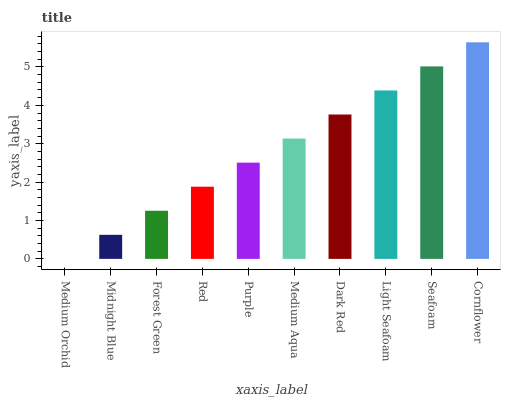Is Medium Orchid the minimum?
Answer yes or no. Yes. Is Cornflower the maximum?
Answer yes or no. Yes. Is Midnight Blue the minimum?
Answer yes or no. No. Is Midnight Blue the maximum?
Answer yes or no. No. Is Midnight Blue greater than Medium Orchid?
Answer yes or no. Yes. Is Medium Orchid less than Midnight Blue?
Answer yes or no. Yes. Is Medium Orchid greater than Midnight Blue?
Answer yes or no. No. Is Midnight Blue less than Medium Orchid?
Answer yes or no. No. Is Medium Aqua the high median?
Answer yes or no. Yes. Is Purple the low median?
Answer yes or no. Yes. Is Seafoam the high median?
Answer yes or no. No. Is Dark Red the low median?
Answer yes or no. No. 